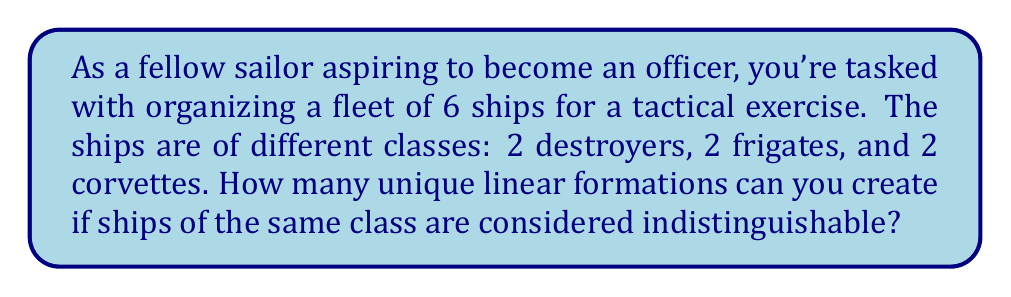What is the answer to this math problem? Let's approach this step-by-step using permutation groups:

1) First, we need to recognize that this is a problem of permutations with repetition. We have 6 positions to fill, but some elements (ships of the same class) are indistinguishable.

2) If all ships were different, we would have 6! permutations. However, we need to account for the indistinguishable ships within each class.

3) For each class (destroyers, frigates, corvettes), we have 2! permutations that don't create a new arrangement. This is because swapping two ships of the same class doesn't create a new formation.

4) Using the orbit-stabilizer theorem from group theory, we can calculate the number of unique formations as:

   $$\frac{6!}{(2! \cdot 2! \cdot 2!)}$$

5) Let's calculate this:
   
   $$\frac{6!}{(2! \cdot 2! \cdot 2!)} = \frac{6 \cdot 5 \cdot 4 \cdot 3 \cdot 2 \cdot 1}{(2 \cdot 1) \cdot (2 \cdot 1) \cdot (2 \cdot 1)}$$

   $$= \frac{720}{8} = 90$$

Therefore, there are 90 unique linear formations possible.
Answer: 90 unique formations 